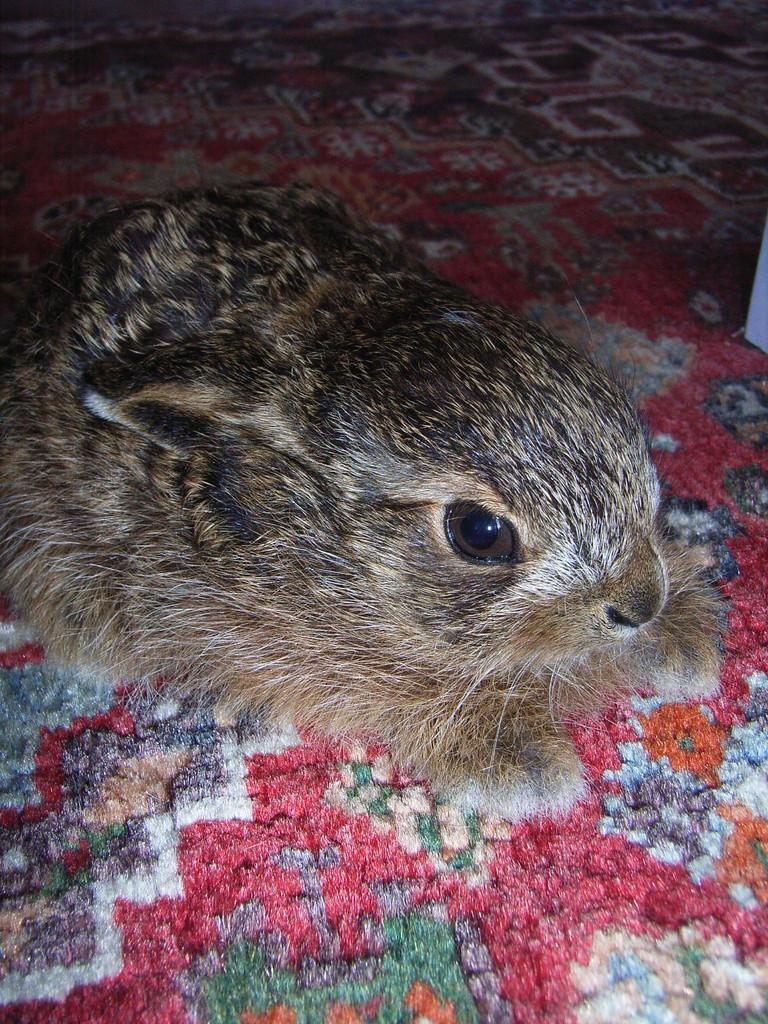What animal is present in the image? There is a rabbit in the image. Where is the rabbit located? The rabbit is on a carpet. How does the rabbit help the doll in the image? There is no doll present in the image, so the rabbit cannot help a doll. 